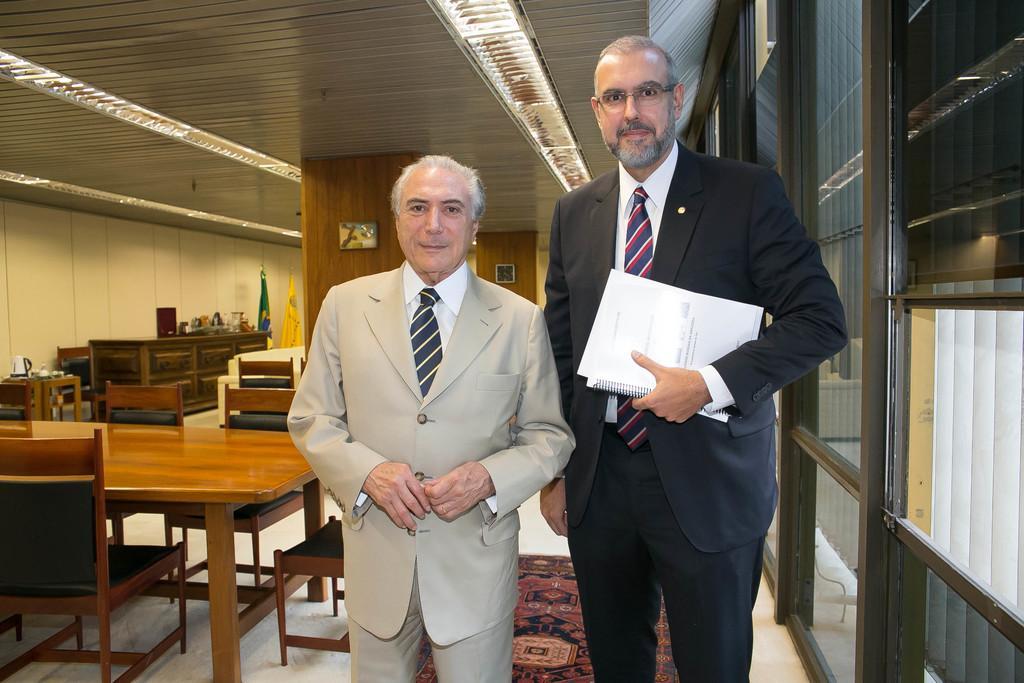Could you give a brief overview of what you see in this image? In a room there are so many tables and chairs and two man standing in room holding papers. 